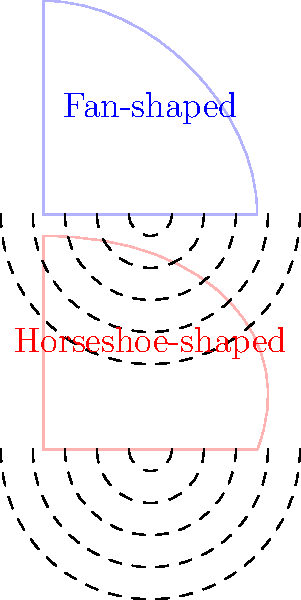As an operatic tenor, you're performing in two different opera houses: one with a fan-shaped design and another with a horseshoe shape. Based on the cross-sectional diagrams shown, which design is likely to provide better acoustics for projecting your voice to the audience, and why? To answer this question, we need to consider the acoustic properties of both designs:

1. Fan-shaped opera house:
   - Wider angle of sound dispersion
   - Fewer reflective surfaces
   - Sound waves spread out more evenly

2. Horseshoe-shaped opera house:
   - Narrower angle of sound dispersion
   - More reflective surfaces (curved walls)
   - Sound waves are focused and reflected multiple times

Step-by-step analysis:
1. Sound reflection: The horseshoe shape provides more surfaces for sound to reflect off, creating a richer, more resonant sound.
2. Sound focus: The curved walls of the horseshoe design help to focus the sound towards the audience, whereas the fan shape allows sound to disperse more widely.
3. Reverberation: The horseshoe shape typically creates more reverberation due to multiple reflections, enhancing the perceived volume and richness of the voice.
4. Intimacy: The horseshoe design often allows for a more intimate setting, with the audience wrapped around the stage, which can improve the connection between performer and audience.
5. Historical precedent: Many famous opera houses, such as La Scala in Milan and the Vienna State Opera, use the horseshoe design, which has been proven effective for operatic performances.

Given these factors, the horseshoe-shaped design is likely to provide better acoustics for projecting an operatic tenor's voice to the audience. The multiple reflections and focused sound projection of this design enhance the voice's resonance and carry it more effectively to all parts of the auditorium.
Answer: Horseshoe-shaped design 